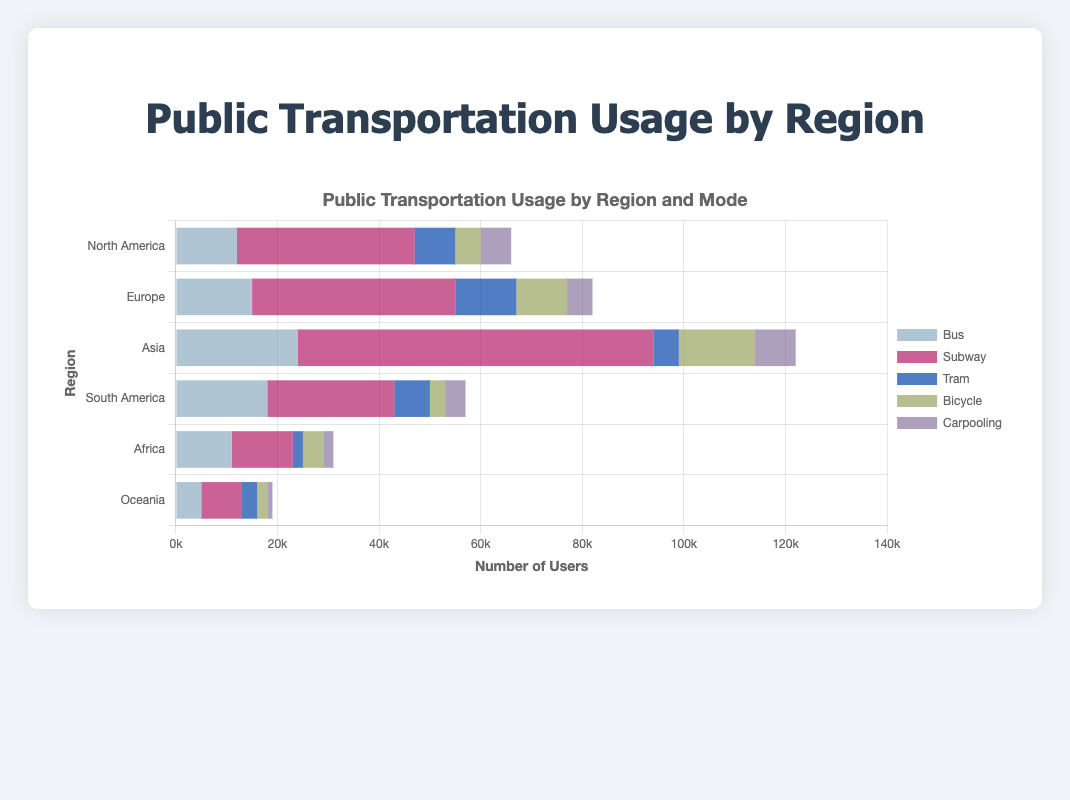Which region has the highest number of bicycle users? By examining the lengths of the bars representing bicycle usage across all regions, it is visible that Asia has the longest bar for bicycles, indicating the highest number of users.
Answer: Asia Which region has the lowest total public transportation usage? To find the region with the lowest total usage, sum up the values for each mode of transportation per region. The sums are: North America (66,000), Europe (82,000), Asia (122,000), South America (57,000), Africa (31,000), and Oceania (19,000). Oceania has the lowest total.
Answer: Oceania What is the total number of subway users in North America and Europe combined? Add the number of subway users in North America (35,000) to the number of subway users in Europe (40,000). The combined total is 35,000 + 40,000 = 75,000.
Answer: 75,000 How does tram usage in Asia compare to that in South America? Compare the lengths of the bars for tram usage in Asia (5,000) and South America (7,000). South America has a higher tram usage than Asia.
Answer: South America has higher tram usage Which region has a higher proportion of bicycle users compared to carpooling: Europe or Africa? Calculate the ratios of bicycle to carpooling users for both regions:
- Europe: 10,000 (Bicycle) / 5,000 (Carpooling) = 2
- Africa: 4,000 (Bicycle) / 2,000 (Carpooling) = 2
Both regions have the same proportion of bicycle to carpooling users.
Answer: Both regions have the same proportion In which region is bus usage nearly equal to subway usage? Checking the values for bus and subway usage in each region:
- North America: Bus (12,000) vs. Subway (35,000)
- Europe: Bus (15,000) vs. Subway (40,000)
- Asia: Bus (24,000) vs. Subway (70,000)
- South America: Bus (18,000) vs. Subway (25,000)
- Africa: Bus (11,000) vs. Subway (12,000)
- Oceania: Bus (5,000) vs. Subway (8,000)
Bus usage is nearly equal to subway usage in Africa.
Answer: Africa Which two regions have the closest total numbers of users for tram and carpooling combined? Calculate the sums of tram and carpooling users for each region:
- North America: 8,000 (Tram) + 6,000 (Carpooling) = 14,000
- Europe: 12,000 (Tram) + 5,000 (Carpooling) = 17,000
- Asia: 5,000 (Tram) + 8,000 (Carpooling) = 13,000
- South America: 7,000 (Tram) + 4,000 (Carpooling) = 11,000
- Africa: 2,000 (Tram) + 2,000 (Carpooling) = 4,000
- Oceania: 3,000 (Tram) + 1,000 (Carpooling) = 4,000
The closest totals are Africa and Oceania, both with 4,000.
Answer: Africa and Oceania 